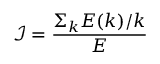Convert formula to latex. <formula><loc_0><loc_0><loc_500><loc_500>\mathcal { I } = \frac { \Sigma _ { k } E ( k ) / k } { E }</formula> 